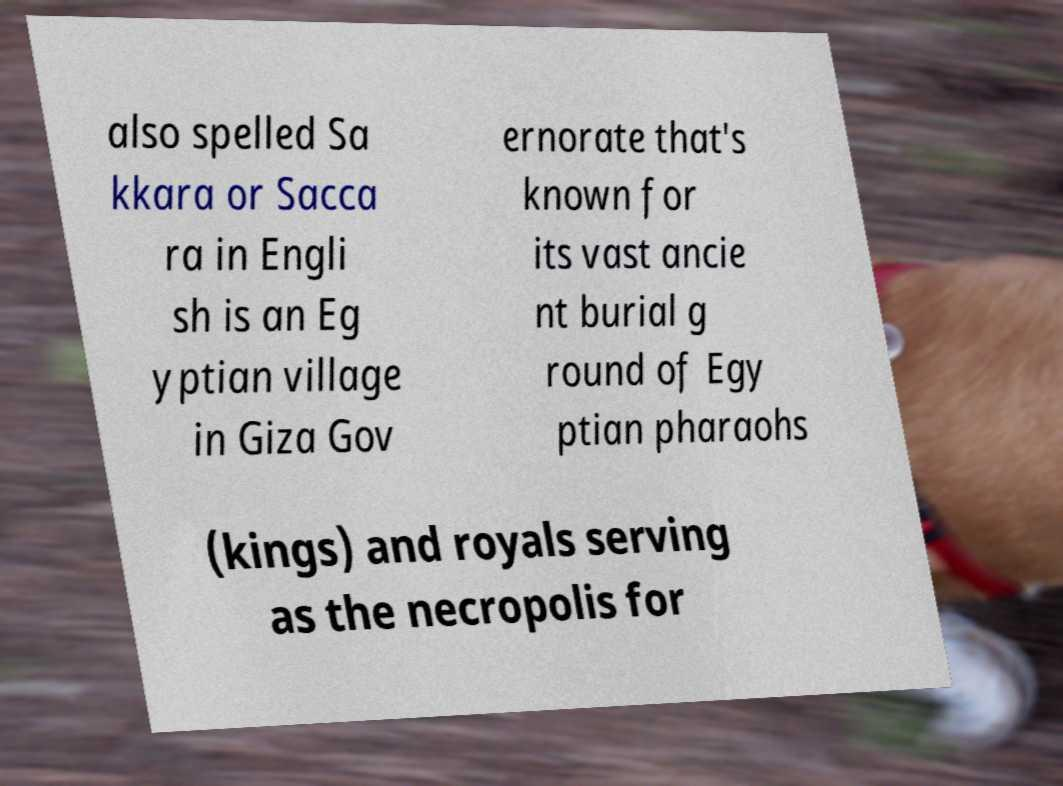Could you extract and type out the text from this image? also spelled Sa kkara or Sacca ra in Engli sh is an Eg yptian village in Giza Gov ernorate that's known for its vast ancie nt burial g round of Egy ptian pharaohs (kings) and royals serving as the necropolis for 